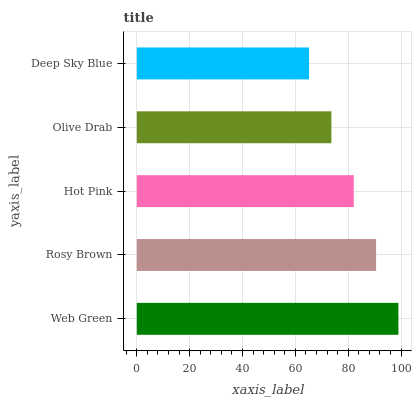Is Deep Sky Blue the minimum?
Answer yes or no. Yes. Is Web Green the maximum?
Answer yes or no. Yes. Is Rosy Brown the minimum?
Answer yes or no. No. Is Rosy Brown the maximum?
Answer yes or no. No. Is Web Green greater than Rosy Brown?
Answer yes or no. Yes. Is Rosy Brown less than Web Green?
Answer yes or no. Yes. Is Rosy Brown greater than Web Green?
Answer yes or no. No. Is Web Green less than Rosy Brown?
Answer yes or no. No. Is Hot Pink the high median?
Answer yes or no. Yes. Is Hot Pink the low median?
Answer yes or no. Yes. Is Deep Sky Blue the high median?
Answer yes or no. No. Is Olive Drab the low median?
Answer yes or no. No. 